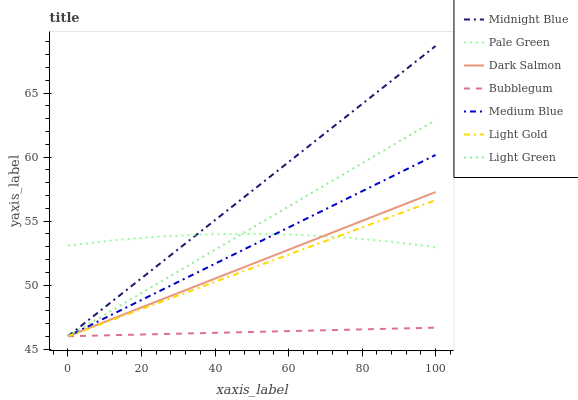Does Bubblegum have the minimum area under the curve?
Answer yes or no. Yes. Does Midnight Blue have the maximum area under the curve?
Answer yes or no. Yes. Does Medium Blue have the minimum area under the curve?
Answer yes or no. No. Does Medium Blue have the maximum area under the curve?
Answer yes or no. No. Is Bubblegum the smoothest?
Answer yes or no. Yes. Is Pale Green the roughest?
Answer yes or no. Yes. Is Medium Blue the smoothest?
Answer yes or no. No. Is Medium Blue the roughest?
Answer yes or no. No. Does Midnight Blue have the lowest value?
Answer yes or no. Yes. Does Pale Green have the lowest value?
Answer yes or no. No. Does Midnight Blue have the highest value?
Answer yes or no. Yes. Does Medium Blue have the highest value?
Answer yes or no. No. Is Bubblegum less than Pale Green?
Answer yes or no. Yes. Is Pale Green greater than Bubblegum?
Answer yes or no. Yes. Does Midnight Blue intersect Medium Blue?
Answer yes or no. Yes. Is Midnight Blue less than Medium Blue?
Answer yes or no. No. Is Midnight Blue greater than Medium Blue?
Answer yes or no. No. Does Bubblegum intersect Pale Green?
Answer yes or no. No. 